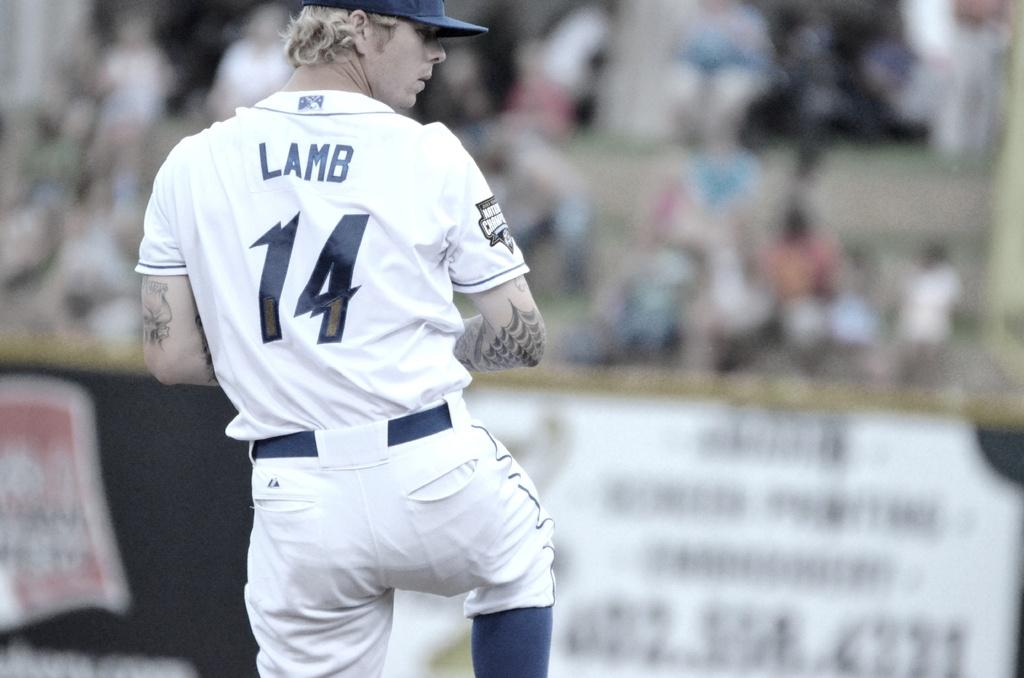Who is about to pitch the ball?
Ensure brevity in your answer.  Lamb. What is the persons' jersey number?
Provide a succinct answer. 14. 